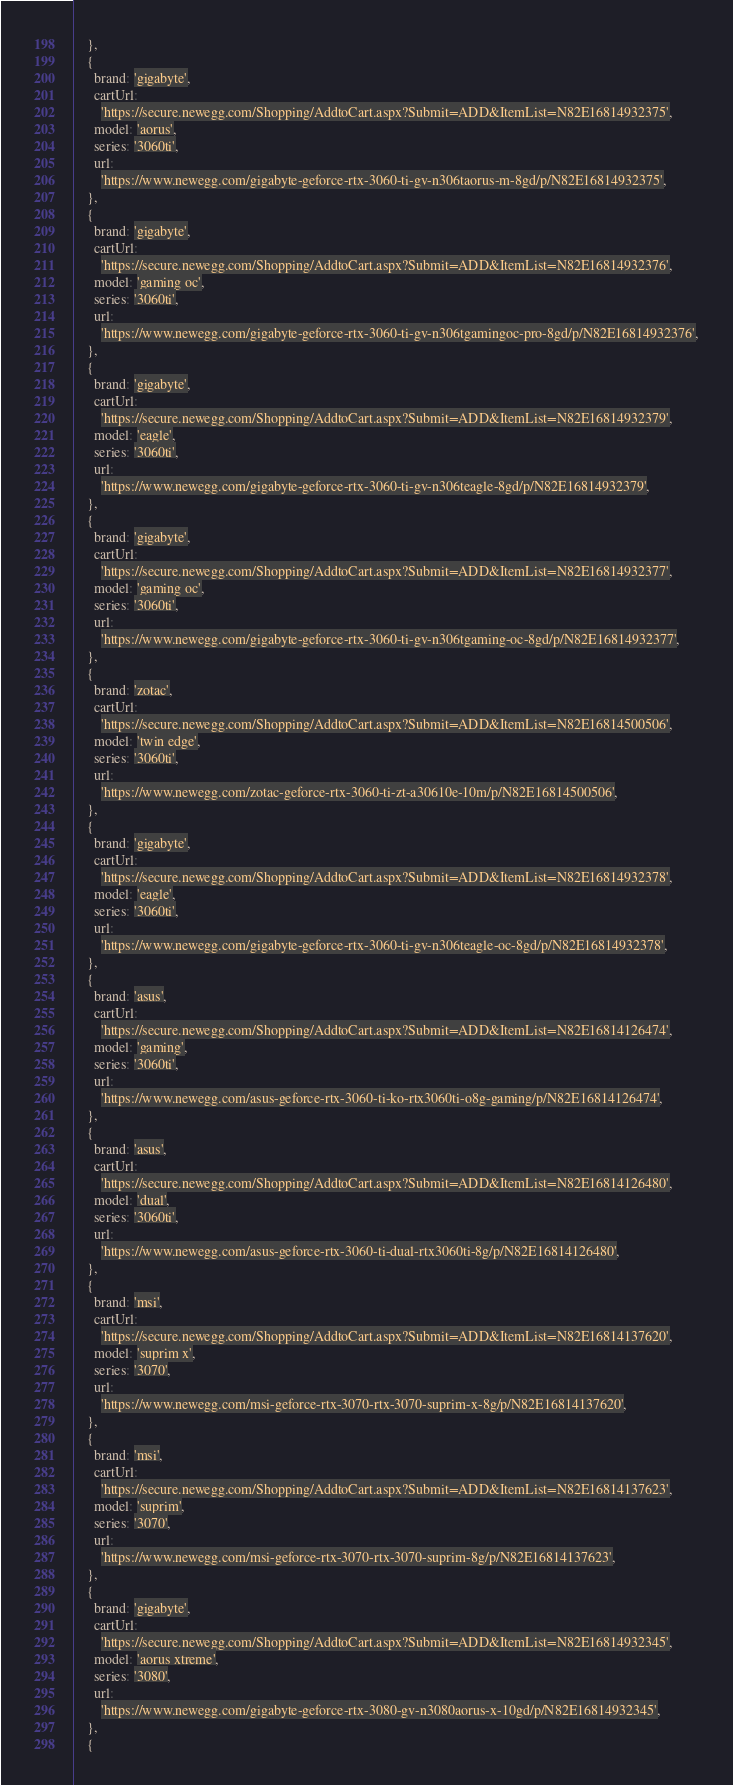Convert code to text. <code><loc_0><loc_0><loc_500><loc_500><_TypeScript_>    },
    {
      brand: 'gigabyte',
      cartUrl:
        'https://secure.newegg.com/Shopping/AddtoCart.aspx?Submit=ADD&ItemList=N82E16814932375',
      model: 'aorus',
      series: '3060ti',
      url:
        'https://www.newegg.com/gigabyte-geforce-rtx-3060-ti-gv-n306taorus-m-8gd/p/N82E16814932375',
    },
    {
      brand: 'gigabyte',
      cartUrl:
        'https://secure.newegg.com/Shopping/AddtoCart.aspx?Submit=ADD&ItemList=N82E16814932376',
      model: 'gaming oc',
      series: '3060ti',
      url:
        'https://www.newegg.com/gigabyte-geforce-rtx-3060-ti-gv-n306tgamingoc-pro-8gd/p/N82E16814932376',
    },
    {
      brand: 'gigabyte',
      cartUrl:
        'https://secure.newegg.com/Shopping/AddtoCart.aspx?Submit=ADD&ItemList=N82E16814932379',
      model: 'eagle',
      series: '3060ti',
      url:
        'https://www.newegg.com/gigabyte-geforce-rtx-3060-ti-gv-n306teagle-8gd/p/N82E16814932379',
    },
    {
      brand: 'gigabyte',
      cartUrl:
        'https://secure.newegg.com/Shopping/AddtoCart.aspx?Submit=ADD&ItemList=N82E16814932377',
      model: 'gaming oc',
      series: '3060ti',
      url:
        'https://www.newegg.com/gigabyte-geforce-rtx-3060-ti-gv-n306tgaming-oc-8gd/p/N82E16814932377',
    },
    {
      brand: 'zotac',
      cartUrl:
        'https://secure.newegg.com/Shopping/AddtoCart.aspx?Submit=ADD&ItemList=N82E16814500506',
      model: 'twin edge',
      series: '3060ti',
      url:
        'https://www.newegg.com/zotac-geforce-rtx-3060-ti-zt-a30610e-10m/p/N82E16814500506',
    },
    {
      brand: 'gigabyte',
      cartUrl:
        'https://secure.newegg.com/Shopping/AddtoCart.aspx?Submit=ADD&ItemList=N82E16814932378',
      model: 'eagle',
      series: '3060ti',
      url:
        'https://www.newegg.com/gigabyte-geforce-rtx-3060-ti-gv-n306teagle-oc-8gd/p/N82E16814932378',
    },
    {
      brand: 'asus',
      cartUrl:
        'https://secure.newegg.com/Shopping/AddtoCart.aspx?Submit=ADD&ItemList=N82E16814126474',
      model: 'gaming',
      series: '3060ti',
      url:
        'https://www.newegg.com/asus-geforce-rtx-3060-ti-ko-rtx3060ti-o8g-gaming/p/N82E16814126474',
    },
    {
      brand: 'asus',
      cartUrl:
        'https://secure.newegg.com/Shopping/AddtoCart.aspx?Submit=ADD&ItemList=N82E16814126480',
      model: 'dual',
      series: '3060ti',
      url:
        'https://www.newegg.com/asus-geforce-rtx-3060-ti-dual-rtx3060ti-8g/p/N82E16814126480',
    },
    {
      brand: 'msi',
      cartUrl:
        'https://secure.newegg.com/Shopping/AddtoCart.aspx?Submit=ADD&ItemList=N82E16814137620',
      model: 'suprim x',
      series: '3070',
      url:
        'https://www.newegg.com/msi-geforce-rtx-3070-rtx-3070-suprim-x-8g/p/N82E16814137620',
    },
    {
      brand: 'msi',
      cartUrl:
        'https://secure.newegg.com/Shopping/AddtoCart.aspx?Submit=ADD&ItemList=N82E16814137623',
      model: 'suprim',
      series: '3070',
      url:
        'https://www.newegg.com/msi-geforce-rtx-3070-rtx-3070-suprim-8g/p/N82E16814137623',
    },
    {
      brand: 'gigabyte',
      cartUrl:
        'https://secure.newegg.com/Shopping/AddtoCart.aspx?Submit=ADD&ItemList=N82E16814932345',
      model: 'aorus xtreme',
      series: '3080',
      url:
        'https://www.newegg.com/gigabyte-geforce-rtx-3080-gv-n3080aorus-x-10gd/p/N82E16814932345',
    },
    {</code> 